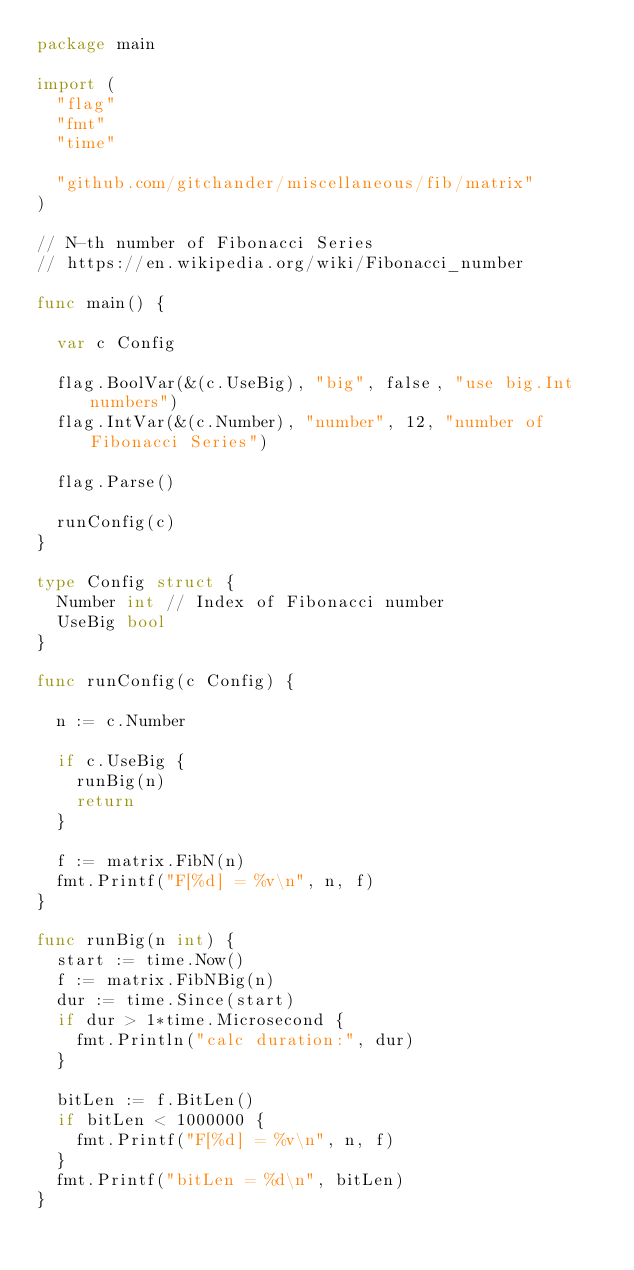Convert code to text. <code><loc_0><loc_0><loc_500><loc_500><_Go_>package main

import (
	"flag"
	"fmt"
	"time"

	"github.com/gitchander/miscellaneous/fib/matrix"
)

// N-th number of Fibonacci Series
// https://en.wikipedia.org/wiki/Fibonacci_number

func main() {

	var c Config

	flag.BoolVar(&(c.UseBig), "big", false, "use big.Int numbers")
	flag.IntVar(&(c.Number), "number", 12, "number of Fibonacci Series")

	flag.Parse()

	runConfig(c)
}

type Config struct {
	Number int // Index of Fibonacci number
	UseBig bool
}

func runConfig(c Config) {

	n := c.Number

	if c.UseBig {
		runBig(n)
		return
	}

	f := matrix.FibN(n)
	fmt.Printf("F[%d] = %v\n", n, f)
}

func runBig(n int) {
	start := time.Now()
	f := matrix.FibNBig(n)
	dur := time.Since(start)
	if dur > 1*time.Microsecond {
		fmt.Println("calc duration:", dur)
	}

	bitLen := f.BitLen()
	if bitLen < 1000000 {
		fmt.Printf("F[%d] = %v\n", n, f)
	}
	fmt.Printf("bitLen = %d\n", bitLen)
}
</code> 